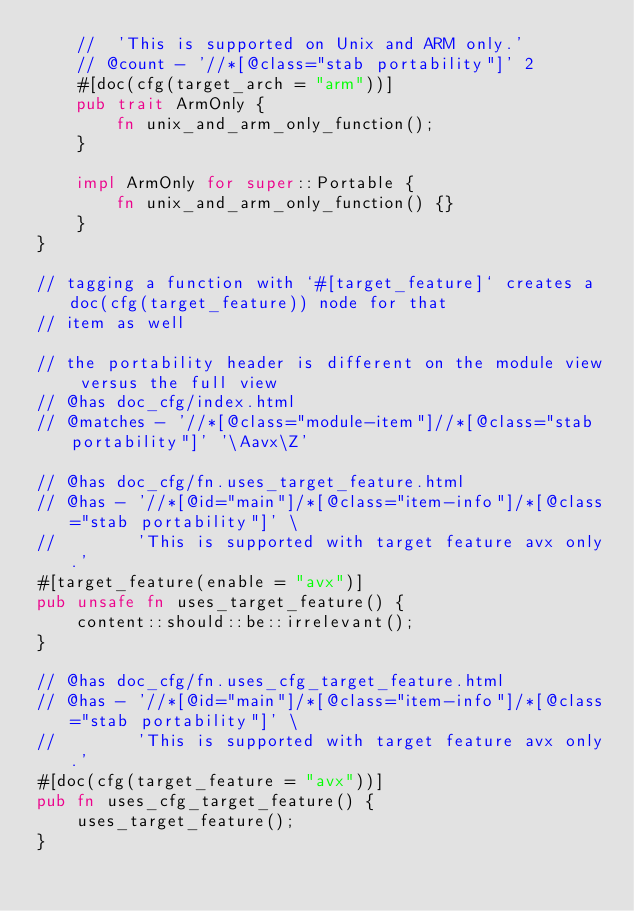<code> <loc_0><loc_0><loc_500><loc_500><_Rust_>    //  'This is supported on Unix and ARM only.'
    // @count - '//*[@class="stab portability"]' 2
    #[doc(cfg(target_arch = "arm"))]
    pub trait ArmOnly {
        fn unix_and_arm_only_function();
    }

    impl ArmOnly for super::Portable {
        fn unix_and_arm_only_function() {}
    }
}

// tagging a function with `#[target_feature]` creates a doc(cfg(target_feature)) node for that
// item as well

// the portability header is different on the module view versus the full view
// @has doc_cfg/index.html
// @matches - '//*[@class="module-item"]//*[@class="stab portability"]' '\Aavx\Z'

// @has doc_cfg/fn.uses_target_feature.html
// @has - '//*[@id="main"]/*[@class="item-info"]/*[@class="stab portability"]' \
//        'This is supported with target feature avx only.'
#[target_feature(enable = "avx")]
pub unsafe fn uses_target_feature() {
    content::should::be::irrelevant();
}

// @has doc_cfg/fn.uses_cfg_target_feature.html
// @has - '//*[@id="main"]/*[@class="item-info"]/*[@class="stab portability"]' \
//        'This is supported with target feature avx only.'
#[doc(cfg(target_feature = "avx"))]
pub fn uses_cfg_target_feature() {
    uses_target_feature();
}
</code> 